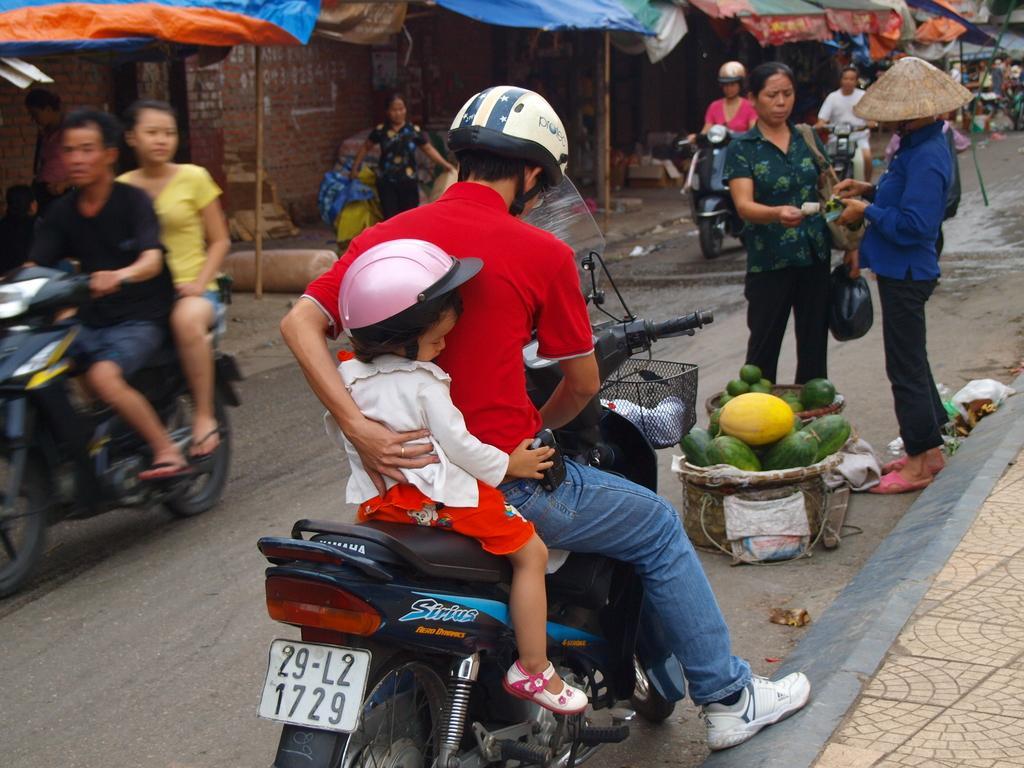Describe this image in one or two sentences. In this picture we can see group of people, few are standing and few people riding motorcycles, on the right side of the image we can see fruits in the baskets, in the background we can find tents. 